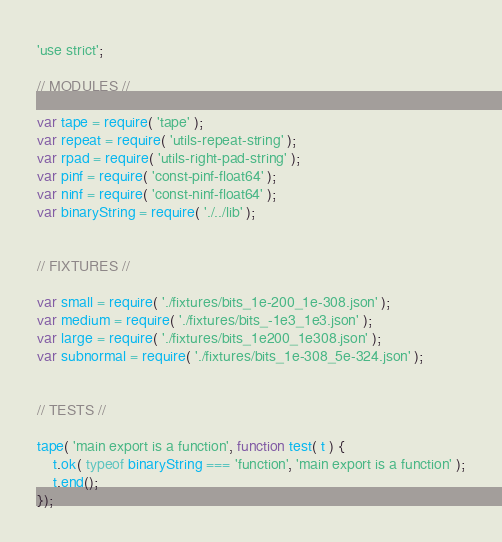Convert code to text. <code><loc_0><loc_0><loc_500><loc_500><_JavaScript_>'use strict';

// MODULES //

var tape = require( 'tape' );
var repeat = require( 'utils-repeat-string' );
var rpad = require( 'utils-right-pad-string' );
var pinf = require( 'const-pinf-float64' );
var ninf = require( 'const-ninf-float64' );
var binaryString = require( './../lib' );


// FIXTURES //

var small = require( './fixtures/bits_1e-200_1e-308.json' );
var medium = require( './fixtures/bits_-1e3_1e3.json' );
var large = require( './fixtures/bits_1e200_1e308.json' );
var subnormal = require( './fixtures/bits_1e-308_5e-324.json' );


// TESTS //

tape( 'main export is a function', function test( t ) {
	t.ok( typeof binaryString === 'function', 'main export is a function' );
	t.end();
});
</code> 